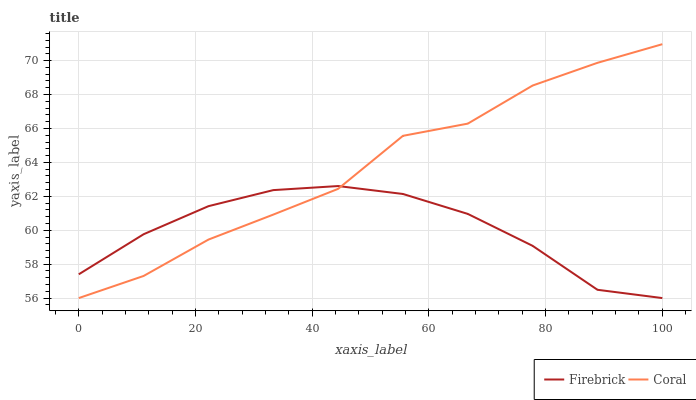Does Firebrick have the minimum area under the curve?
Answer yes or no. Yes. Does Coral have the maximum area under the curve?
Answer yes or no. Yes. Does Coral have the minimum area under the curve?
Answer yes or no. No. Is Firebrick the smoothest?
Answer yes or no. Yes. Is Coral the roughest?
Answer yes or no. Yes. Is Coral the smoothest?
Answer yes or no. No. Does Firebrick have the lowest value?
Answer yes or no. Yes. Does Coral have the highest value?
Answer yes or no. Yes. Does Coral intersect Firebrick?
Answer yes or no. Yes. Is Coral less than Firebrick?
Answer yes or no. No. Is Coral greater than Firebrick?
Answer yes or no. No. 